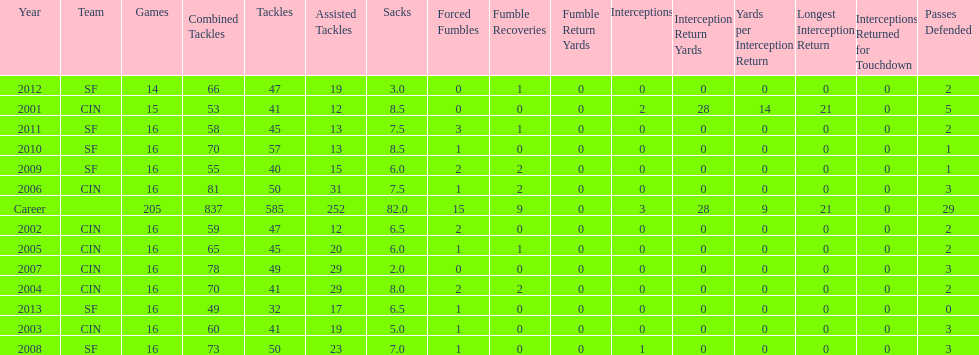What is the only season he has fewer than three sacks? 2007. 